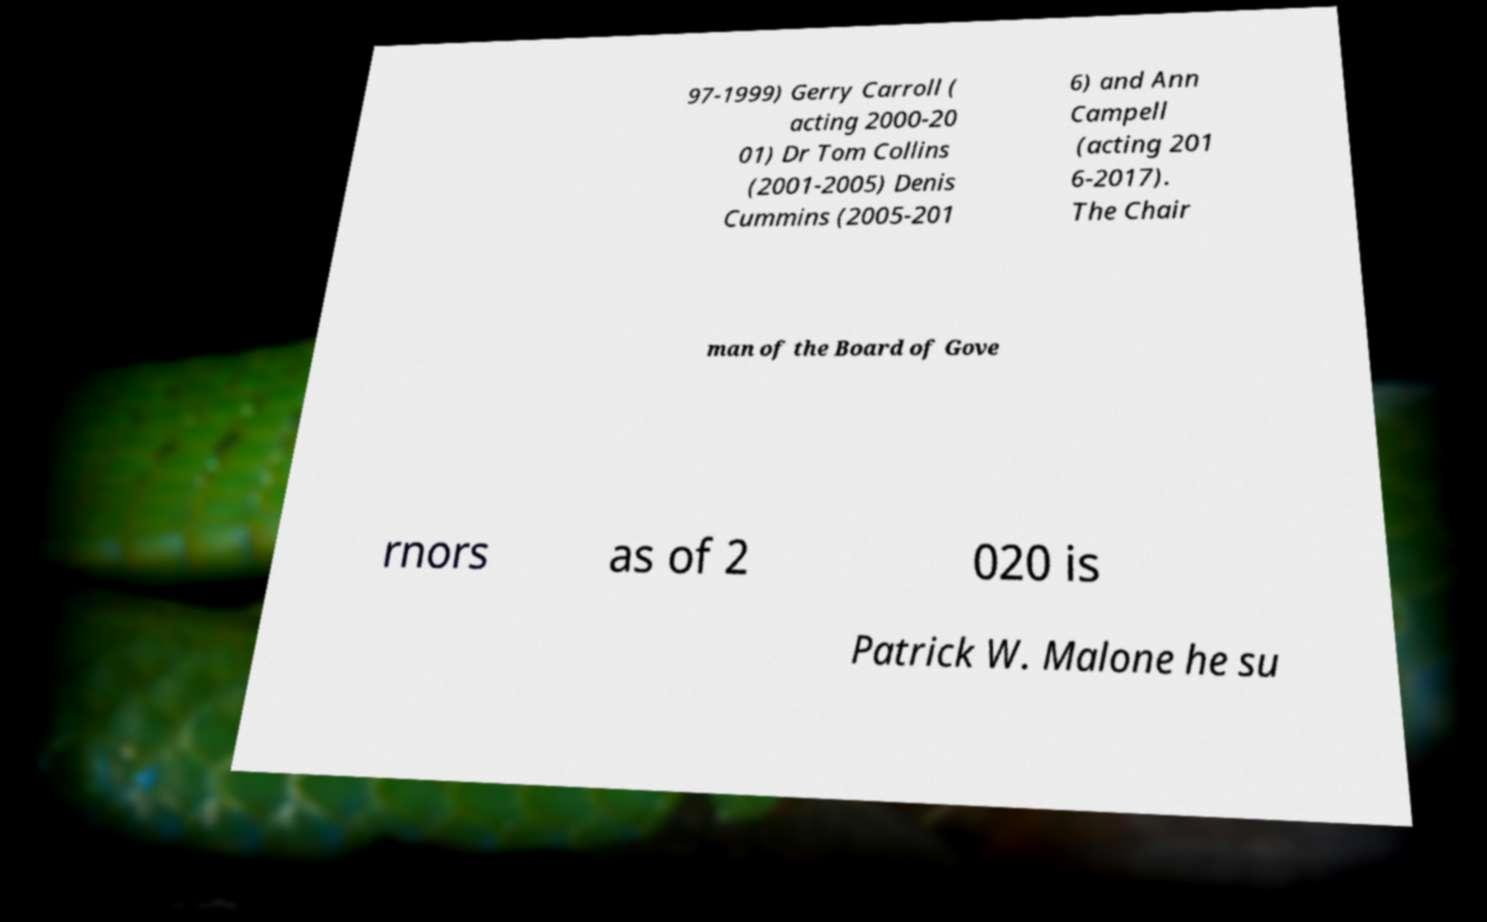Please identify and transcribe the text found in this image. 97-1999) Gerry Carroll ( acting 2000-20 01) Dr Tom Collins (2001-2005) Denis Cummins (2005-201 6) and Ann Campell (acting 201 6-2017). The Chair man of the Board of Gove rnors as of 2 020 is Patrick W. Malone he su 